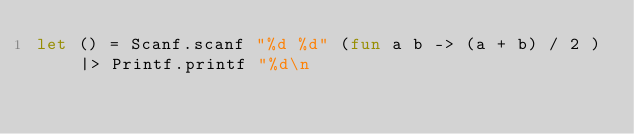Convert code to text. <code><loc_0><loc_0><loc_500><loc_500><_OCaml_>let () = Scanf.scanf "%d %d" (fun a b -> (a + b) / 2 ) |> Printf.printf "%d\n</code> 